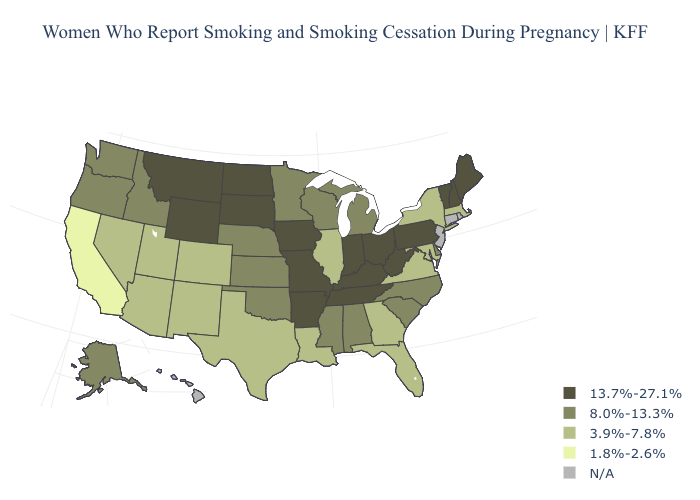Among the states that border Maryland , which have the lowest value?
Be succinct. Virginia. Name the states that have a value in the range 8.0%-13.3%?
Give a very brief answer. Alabama, Alaska, Delaware, Idaho, Kansas, Michigan, Minnesota, Mississippi, Nebraska, North Carolina, Oklahoma, Oregon, South Carolina, Washington, Wisconsin. Does Massachusetts have the highest value in the Northeast?
Concise answer only. No. Which states hav the highest value in the MidWest?
Answer briefly. Indiana, Iowa, Missouri, North Dakota, Ohio, South Dakota. Does the first symbol in the legend represent the smallest category?
Write a very short answer. No. What is the value of West Virginia?
Keep it brief. 13.7%-27.1%. Does New York have the highest value in the Northeast?
Concise answer only. No. Does Texas have the lowest value in the South?
Keep it brief. Yes. What is the highest value in states that border Arizona?
Short answer required. 3.9%-7.8%. What is the highest value in the West ?
Give a very brief answer. 13.7%-27.1%. Name the states that have a value in the range 1.8%-2.6%?
Write a very short answer. California. What is the lowest value in the Northeast?
Be succinct. 3.9%-7.8%. Name the states that have a value in the range N/A?
Concise answer only. Connecticut, Hawaii, New Jersey, Rhode Island. Name the states that have a value in the range 13.7%-27.1%?
Write a very short answer. Arkansas, Indiana, Iowa, Kentucky, Maine, Missouri, Montana, New Hampshire, North Dakota, Ohio, Pennsylvania, South Dakota, Tennessee, Vermont, West Virginia, Wyoming. Does Tennessee have the highest value in the USA?
Short answer required. Yes. 